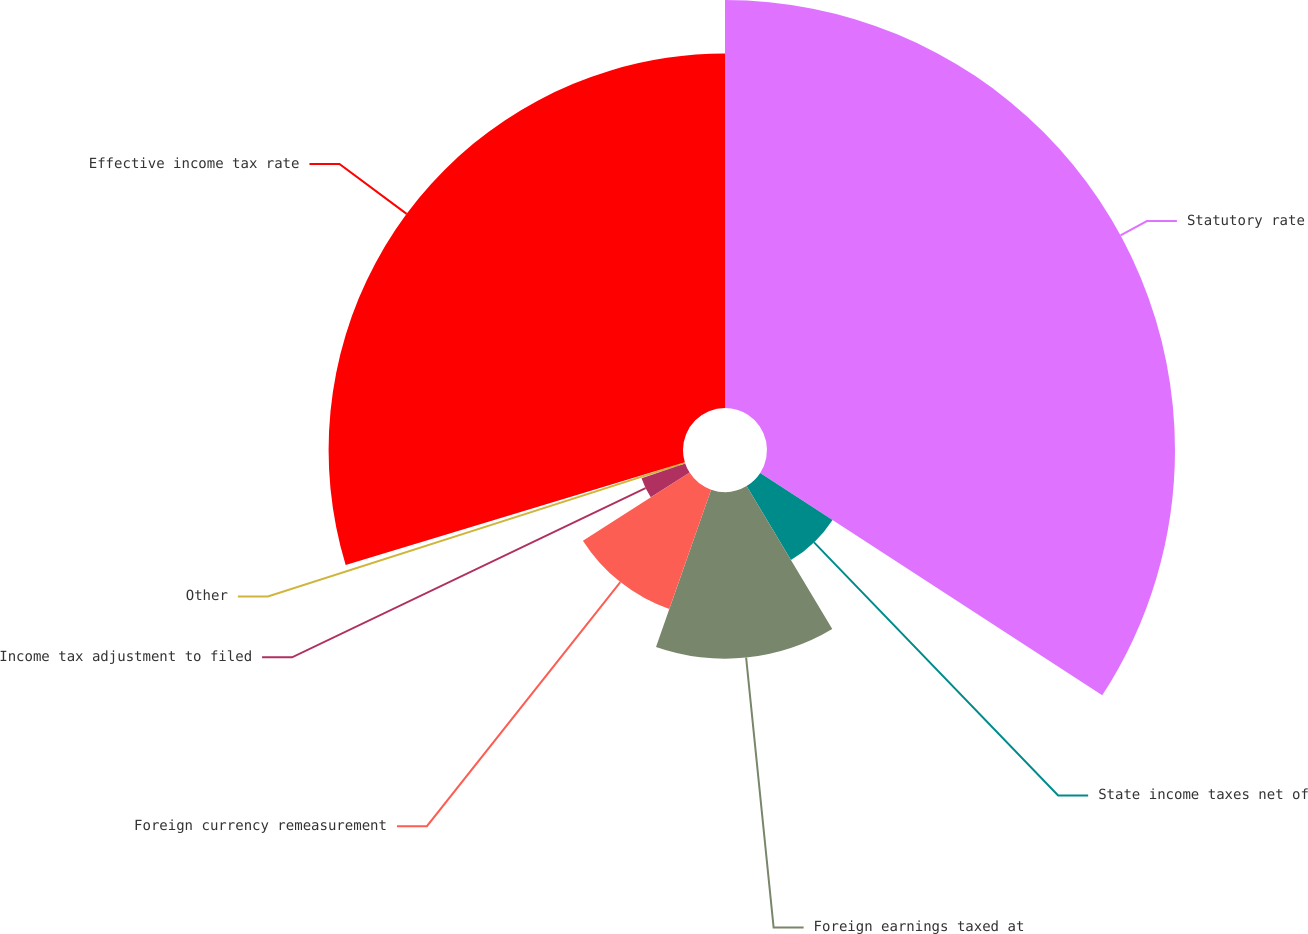Convert chart to OTSL. <chart><loc_0><loc_0><loc_500><loc_500><pie_chart><fcel>Statutory rate<fcel>State income taxes net of<fcel>Foreign earnings taxed at<fcel>Foreign currency remeasurement<fcel>Income tax adjustment to filed<fcel>Other<fcel>Effective income tax rate<nl><fcel>34.18%<fcel>7.23%<fcel>13.96%<fcel>10.6%<fcel>3.86%<fcel>0.49%<fcel>29.69%<nl></chart> 